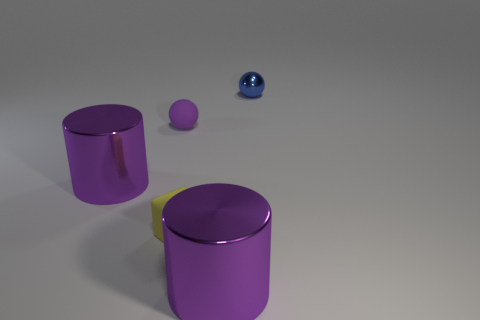Are there any other things of the same color as the tiny metallic object?
Your answer should be compact. No. What number of other things have the same shape as the tiny blue thing?
Give a very brief answer. 1. Do the object to the left of the small purple matte object and the rubber ball have the same color?
Offer a terse response. Yes. There is a large purple thing that is in front of the tiny matte cube that is in front of the big purple metal thing to the left of the tiny purple matte ball; what shape is it?
Make the answer very short. Cylinder. Does the matte cube have the same size as the rubber object behind the tiny yellow block?
Give a very brief answer. Yes. Is there a block that has the same size as the yellow rubber thing?
Your response must be concise. No. How many other things are there of the same material as the small purple ball?
Your response must be concise. 1. What is the color of the metal object that is right of the purple matte thing and in front of the tiny purple rubber ball?
Provide a short and direct response. Purple. Is the purple cylinder that is on the right side of the tiny yellow matte block made of the same material as the small purple sphere behind the small yellow object?
Make the answer very short. No. There is a yellow rubber object that is in front of the purple matte ball; does it have the same size as the small rubber sphere?
Offer a terse response. Yes. 